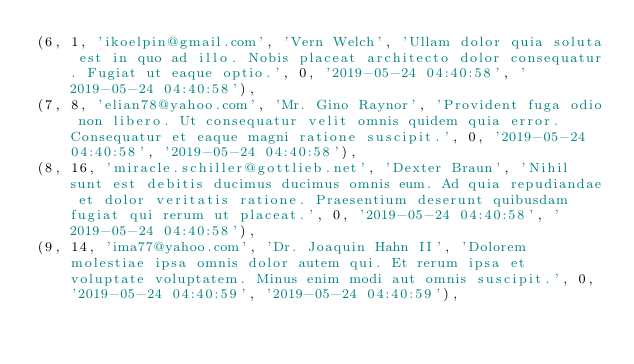Convert code to text. <code><loc_0><loc_0><loc_500><loc_500><_SQL_>(6, 1, 'ikoelpin@gmail.com', 'Vern Welch', 'Ullam dolor quia soluta est in quo ad illo. Nobis placeat architecto dolor consequatur. Fugiat ut eaque optio.', 0, '2019-05-24 04:40:58', '2019-05-24 04:40:58'),
(7, 8, 'elian78@yahoo.com', 'Mr. Gino Raynor', 'Provident fuga odio non libero. Ut consequatur velit omnis quidem quia error. Consequatur et eaque magni ratione suscipit.', 0, '2019-05-24 04:40:58', '2019-05-24 04:40:58'),
(8, 16, 'miracle.schiller@gottlieb.net', 'Dexter Braun', 'Nihil sunt est debitis ducimus ducimus omnis eum. Ad quia repudiandae et dolor veritatis ratione. Praesentium deserunt quibusdam fugiat qui rerum ut placeat.', 0, '2019-05-24 04:40:58', '2019-05-24 04:40:58'),
(9, 14, 'ima77@yahoo.com', 'Dr. Joaquin Hahn II', 'Dolorem molestiae ipsa omnis dolor autem qui. Et rerum ipsa et voluptate voluptatem. Minus enim modi aut omnis suscipit.', 0, '2019-05-24 04:40:59', '2019-05-24 04:40:59'),</code> 